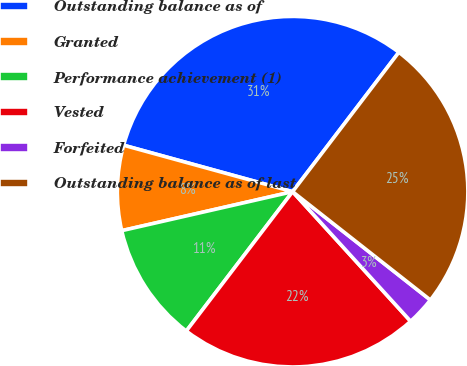Convert chart. <chart><loc_0><loc_0><loc_500><loc_500><pie_chart><fcel>Outstanding balance as of<fcel>Granted<fcel>Performance achievement (1)<fcel>Vested<fcel>Forfeited<fcel>Outstanding balance as of last<nl><fcel>31.1%<fcel>7.84%<fcel>11.06%<fcel>22.13%<fcel>2.64%<fcel>25.24%<nl></chart> 